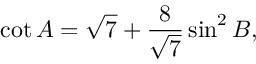Convert formula to latex. <formula><loc_0><loc_0><loc_500><loc_500>\cot A = { \sqrt { 7 } } + { \frac { 8 } { \sqrt { 7 } } } \sin ^ { 2 } B ,</formula> 